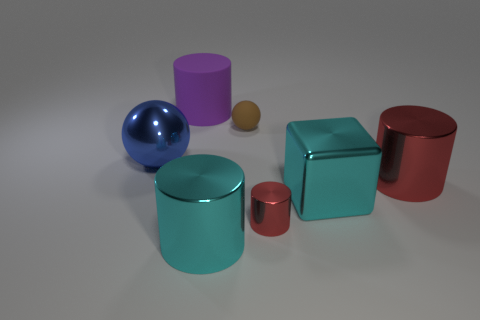Do the tiny red cylinder and the big cylinder to the right of the tiny sphere have the same material?
Offer a very short reply. Yes. How many big things are red objects or purple cylinders?
Offer a very short reply. 2. There is a large thing that is the same color as the small shiny thing; what is it made of?
Provide a succinct answer. Metal. Is the number of tiny yellow balls less than the number of purple rubber cylinders?
Make the answer very short. Yes. There is a thing that is behind the tiny matte sphere; does it have the same size as the red cylinder that is in front of the cyan cube?
Offer a very short reply. No. How many gray things are large cubes or cylinders?
Your answer should be very brief. 0. The metal cylinder that is the same color as the big cube is what size?
Make the answer very short. Large. Are there more large red metallic balls than matte balls?
Keep it short and to the point. No. Do the metallic block and the small shiny object have the same color?
Give a very brief answer. No. What number of things are big yellow rubber cylinders or large objects that are to the right of the purple cylinder?
Offer a terse response. 3. 